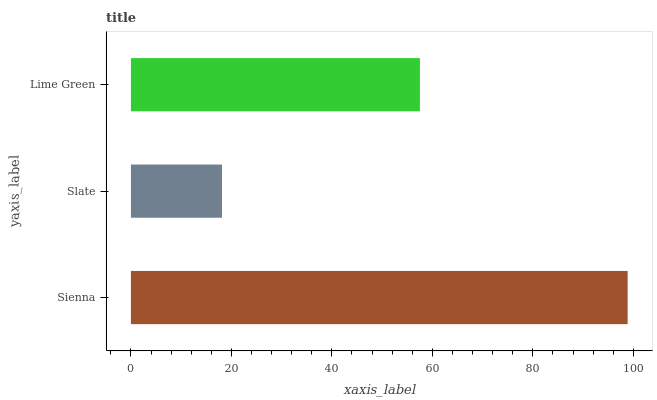Is Slate the minimum?
Answer yes or no. Yes. Is Sienna the maximum?
Answer yes or no. Yes. Is Lime Green the minimum?
Answer yes or no. No. Is Lime Green the maximum?
Answer yes or no. No. Is Lime Green greater than Slate?
Answer yes or no. Yes. Is Slate less than Lime Green?
Answer yes or no. Yes. Is Slate greater than Lime Green?
Answer yes or no. No. Is Lime Green less than Slate?
Answer yes or no. No. Is Lime Green the high median?
Answer yes or no. Yes. Is Lime Green the low median?
Answer yes or no. Yes. Is Slate the high median?
Answer yes or no. No. Is Sienna the low median?
Answer yes or no. No. 